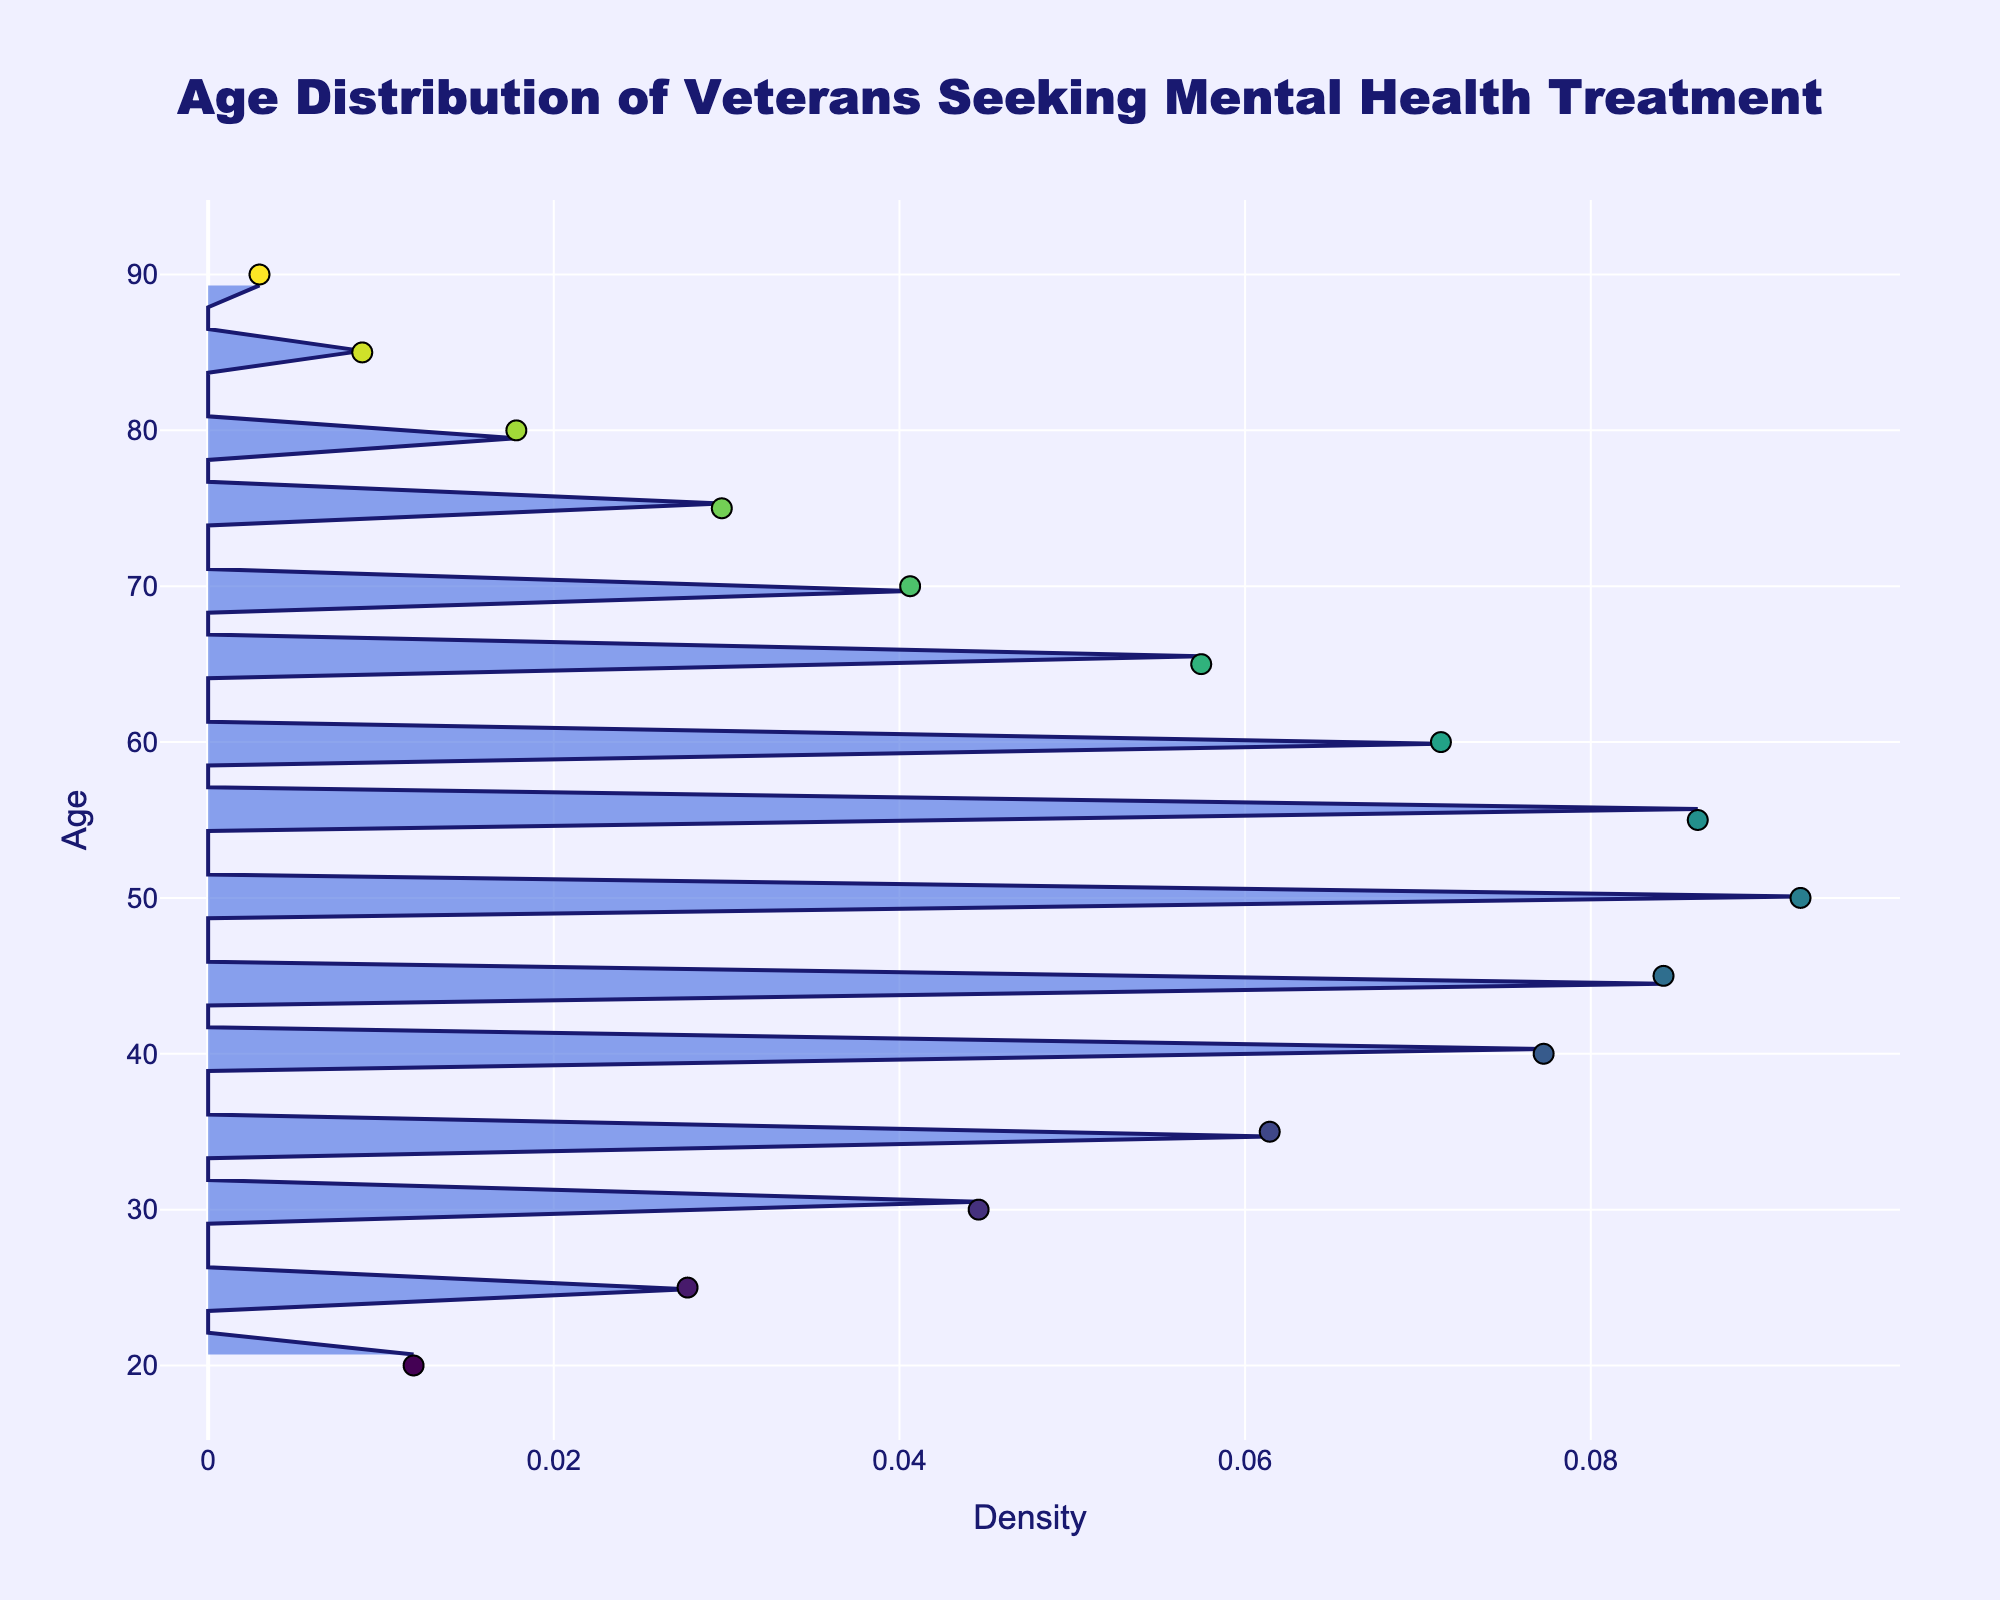What is the title of the figure? The title of the figure is usually found at the top of the chart and provides a summary of what the data is about. In this case, it reads 'Age Distribution of Veterans Seeking Mental Health Treatment'.
Answer: Age Distribution of Veterans Seeking Mental Health Treatment What does the x-axis represent? By looking at the label of the x-axis, it indicates that it represents 'Density'. This tells us how densely populated the data is regarding the age distribution.
Answer: Density What age has the highest frequency of veterans seeking mental health treatment? Observing the density plot and the markers, the peak of the highest density corresponds to a specific age group. The age group with the highest density and frequency is at age 50.
Answer: 50 Which age group has the lowest frequency of veterans seeking mental health treatment? To determine this, look at the age with the smallest marker count or the lowest density in the chart. The smallest frequencies are at the tail ends of the distribution. The age of 90 has the lowest frequency.
Answer: 90 What is the general age trend of veterans seeking mental health treatment? By examining the density plot, we can see that the density increases up to a certain point and then gradually decreases. This indicates that as age increases, more veterans initially seek treatment up to age 50, after which the number decreases.
Answer: Peaks around age 50, then declines What can you deduce about the age distribution symmetry? Noting the shape of the density plot, if the peak is centrally located and both tails are approximately equal, the distribution is symmetric. Here, the distribution peaks at age 50 and declines, exhibiting slight skewness.
Answer: Slightly skewed How does the frequency of veterans seeking mental health treatment at age 45 compare to age 75? Comparing the data points and density heights between these ages on the chart, the frequency at age 45 is much higher than at age 75. Specifically, age 45 has 85 instances, while age 75 has 30.
Answer: Higher at age 45 than at age 75 What is the significance of the color gradient in the data points? The color gradient of the markers typically represents the age groups on a continuous scale. The legend or gradient shows that colors change as age increases. The 'Viridis' color scale indicates that color intensities vary with age.
Answer: Represents age intensities What does the shaded area in the density plot indicate? The shaded area under the curve of the density plot represents the probability density for each age group. It demonstrates how likely veterans of specific ages seek mental health treatment. A larger shaded area indicates higher density.
Answer: Probability density How many age groups have a frequency greater than 50 veterans? To find this, count all data markers (age points) with a frequency over 50. Here, ages 35, 40, 45, 50, and 55 have frequencies above 50.
Answer: Five (35, 40, 45, 50, 55) What is the predominant age range for seeking mental health treatment? By observing the overall shape and span of the density curve, the predominant age range is determined by where the density is highest. The main bulk and highest density is between ages 30 and 60.
Answer: 30-60 